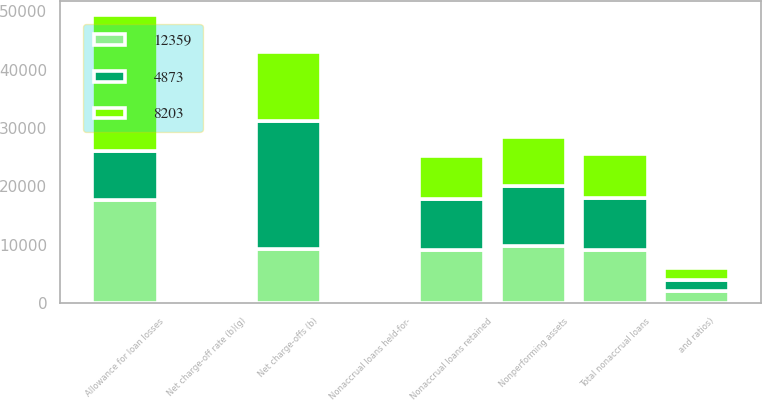Convert chart. <chart><loc_0><loc_0><loc_500><loc_500><stacked_bar_chart><ecel><fcel>and ratios)<fcel>Net charge-offs (b)<fcel>Nonaccrual loans retained<fcel>Nonaccrual loans held-for-<fcel>Total nonaccrual loans<fcel>Nonperforming assets<fcel>Allowance for loan losses<fcel>Net charge-off rate (b)(g)<nl><fcel>12359<fcel>2012<fcel>9280<fcel>9114<fcel>39<fcel>9153<fcel>9830<fcel>17752<fcel>2.27<nl><fcel>8203<fcel>2011<fcel>11815<fcel>7354<fcel>103<fcel>7457<fcel>8292<fcel>23256<fcel>2.75<nl><fcel>4873<fcel>2010<fcel>21943<fcel>8770<fcel>145<fcel>8915<fcel>10268<fcel>8292<fcel>4.61<nl></chart> 